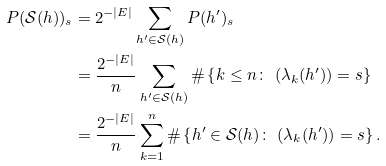<formula> <loc_0><loc_0><loc_500><loc_500>P ( \mathcal { S } ( h ) ) _ { s } & = 2 ^ { - | E | } \sum _ { h ^ { \prime } \in \mathcal { S } ( h ) } P ( h ^ { \prime } ) _ { s } \\ & = \frac { 2 ^ { - | E | } } { n } \sum _ { h ^ { \prime } \in \mathcal { S } ( h ) } \# \left \{ k \leq n \colon \ ( \lambda _ { k } ( h ^ { \prime } ) ) = s \right \} \\ & = \frac { 2 ^ { - | E | } } { n } \sum _ { k = 1 } ^ { n } \# \left \{ h ^ { \prime } \in \mathcal { S } ( h ) \colon \ ( \lambda _ { k } ( h ^ { \prime } ) ) = s \right \} .</formula> 